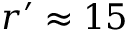<formula> <loc_0><loc_0><loc_500><loc_500>r ^ { \prime } \approx 1 5</formula> 